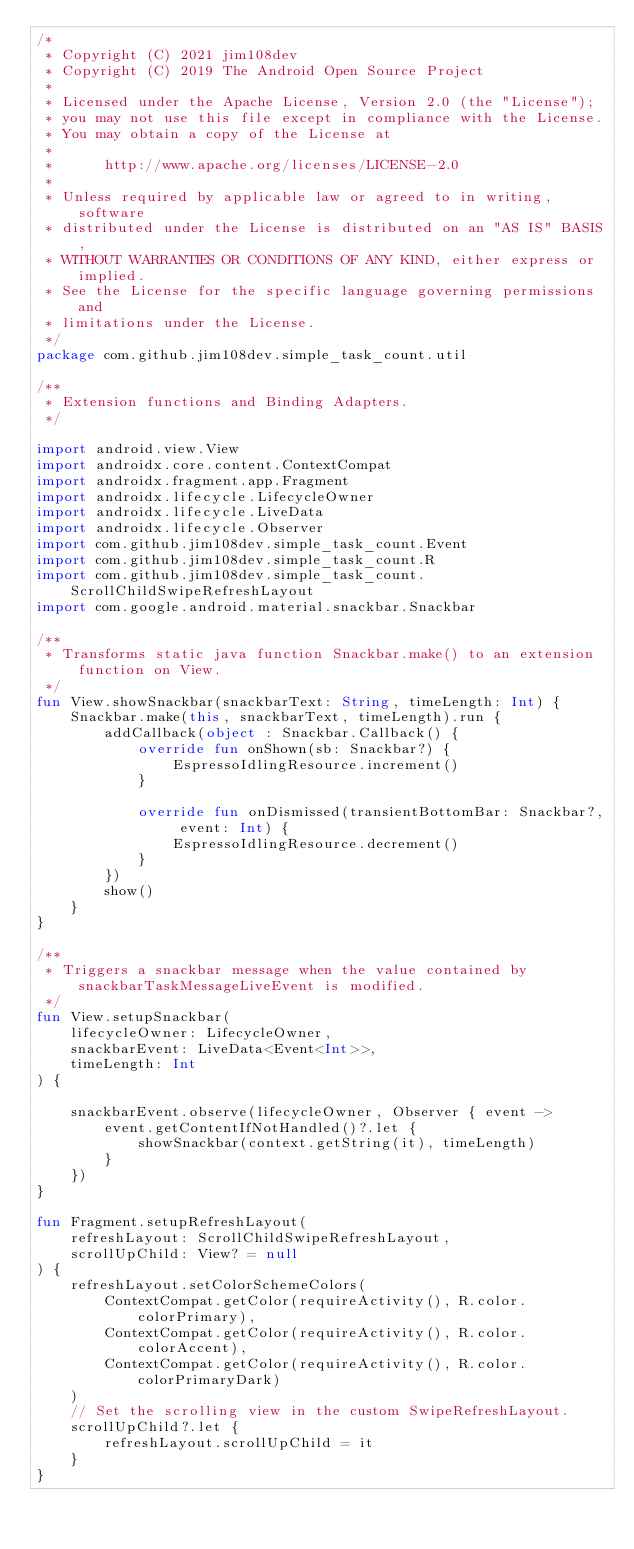<code> <loc_0><loc_0><loc_500><loc_500><_Kotlin_>/*
 * Copyright (C) 2021 jim108dev
 * Copyright (C) 2019 The Android Open Source Project
 *
 * Licensed under the Apache License, Version 2.0 (the "License");
 * you may not use this file except in compliance with the License.
 * You may obtain a copy of the License at
 *
 *      http://www.apache.org/licenses/LICENSE-2.0
 *
 * Unless required by applicable law or agreed to in writing, software
 * distributed under the License is distributed on an "AS IS" BASIS,
 * WITHOUT WARRANTIES OR CONDITIONS OF ANY KIND, either express or implied.
 * See the License for the specific language governing permissions and
 * limitations under the License.
 */
package com.github.jim108dev.simple_task_count.util

/**
 * Extension functions and Binding Adapters.
 */

import android.view.View
import androidx.core.content.ContextCompat
import androidx.fragment.app.Fragment
import androidx.lifecycle.LifecycleOwner
import androidx.lifecycle.LiveData
import androidx.lifecycle.Observer
import com.github.jim108dev.simple_task_count.Event
import com.github.jim108dev.simple_task_count.R
import com.github.jim108dev.simple_task_count.ScrollChildSwipeRefreshLayout
import com.google.android.material.snackbar.Snackbar

/**
 * Transforms static java function Snackbar.make() to an extension function on View.
 */
fun View.showSnackbar(snackbarText: String, timeLength: Int) {
    Snackbar.make(this, snackbarText, timeLength).run {
        addCallback(object : Snackbar.Callback() {
            override fun onShown(sb: Snackbar?) {
                EspressoIdlingResource.increment()
            }

            override fun onDismissed(transientBottomBar: Snackbar?, event: Int) {
                EspressoIdlingResource.decrement()
            }
        })
        show()
    }
}

/**
 * Triggers a snackbar message when the value contained by snackbarTaskMessageLiveEvent is modified.
 */
fun View.setupSnackbar(
    lifecycleOwner: LifecycleOwner,
    snackbarEvent: LiveData<Event<Int>>,
    timeLength: Int
) {

    snackbarEvent.observe(lifecycleOwner, Observer { event ->
        event.getContentIfNotHandled()?.let {
            showSnackbar(context.getString(it), timeLength)
        }
    })
}

fun Fragment.setupRefreshLayout(
    refreshLayout: ScrollChildSwipeRefreshLayout,
    scrollUpChild: View? = null
) {
    refreshLayout.setColorSchemeColors(
        ContextCompat.getColor(requireActivity(), R.color.colorPrimary),
        ContextCompat.getColor(requireActivity(), R.color.colorAccent),
        ContextCompat.getColor(requireActivity(), R.color.colorPrimaryDark)
    )
    // Set the scrolling view in the custom SwipeRefreshLayout.
    scrollUpChild?.let {
        refreshLayout.scrollUpChild = it
    }
}
</code> 